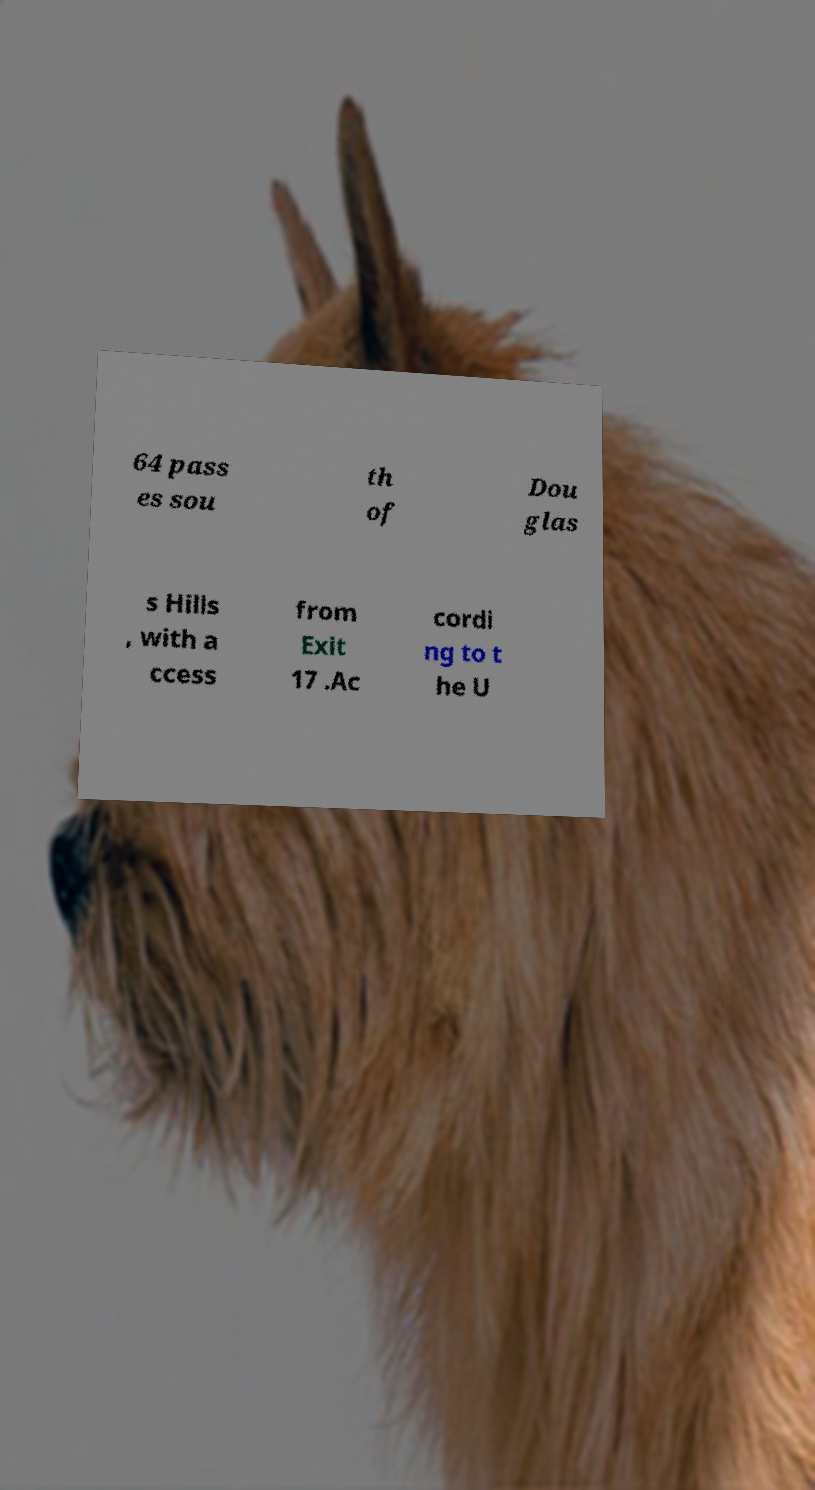There's text embedded in this image that I need extracted. Can you transcribe it verbatim? 64 pass es sou th of Dou glas s Hills , with a ccess from Exit 17 .Ac cordi ng to t he U 